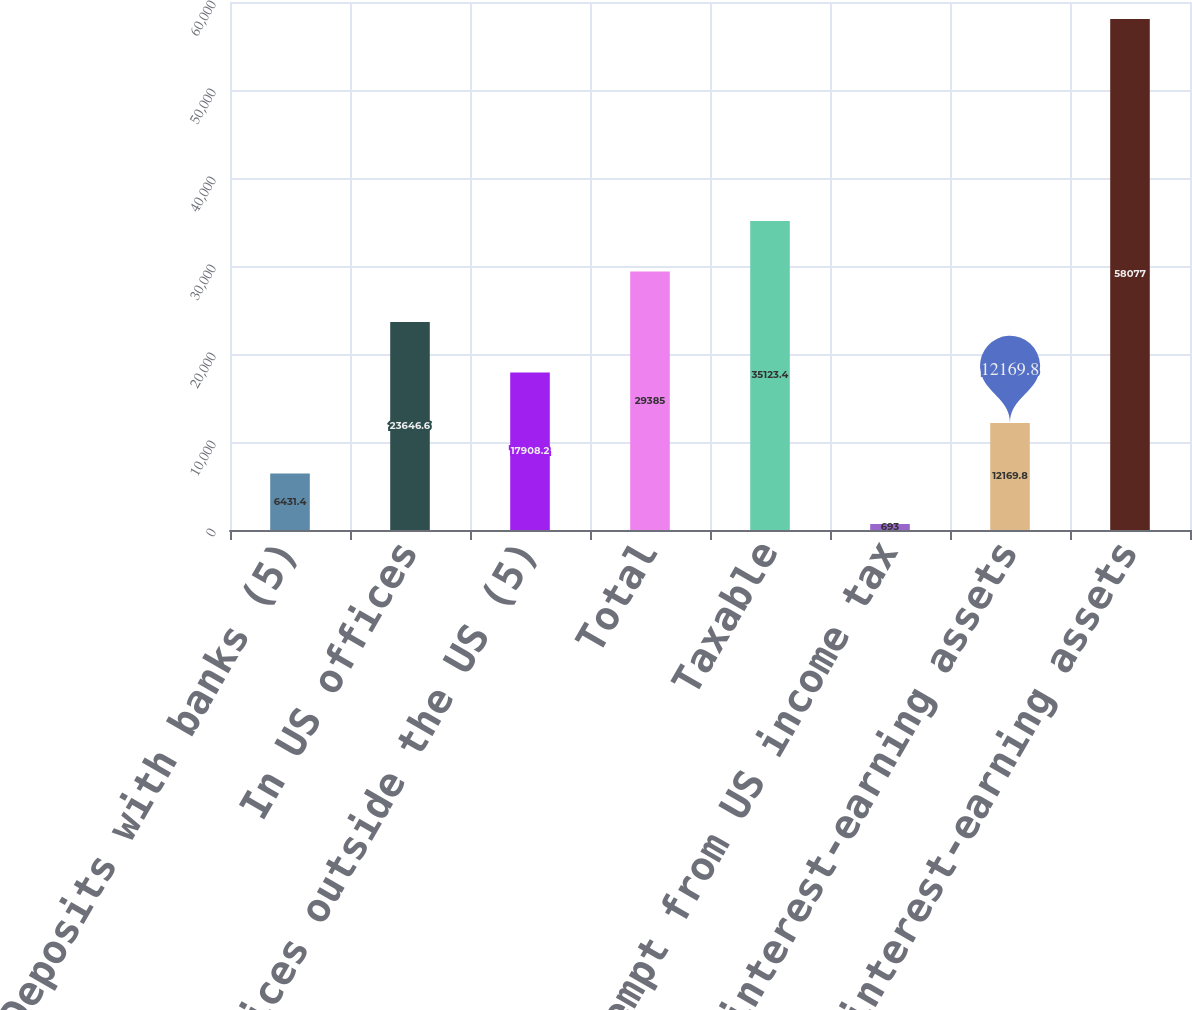Convert chart to OTSL. <chart><loc_0><loc_0><loc_500><loc_500><bar_chart><fcel>Deposits with banks (5)<fcel>In US offices<fcel>In offices outside the US (5)<fcel>Total<fcel>Taxable<fcel>Exempt from US income tax<fcel>Other interest-earning assets<fcel>Total interest-earning assets<nl><fcel>6431.4<fcel>23646.6<fcel>17908.2<fcel>29385<fcel>35123.4<fcel>693<fcel>12169.8<fcel>58077<nl></chart> 